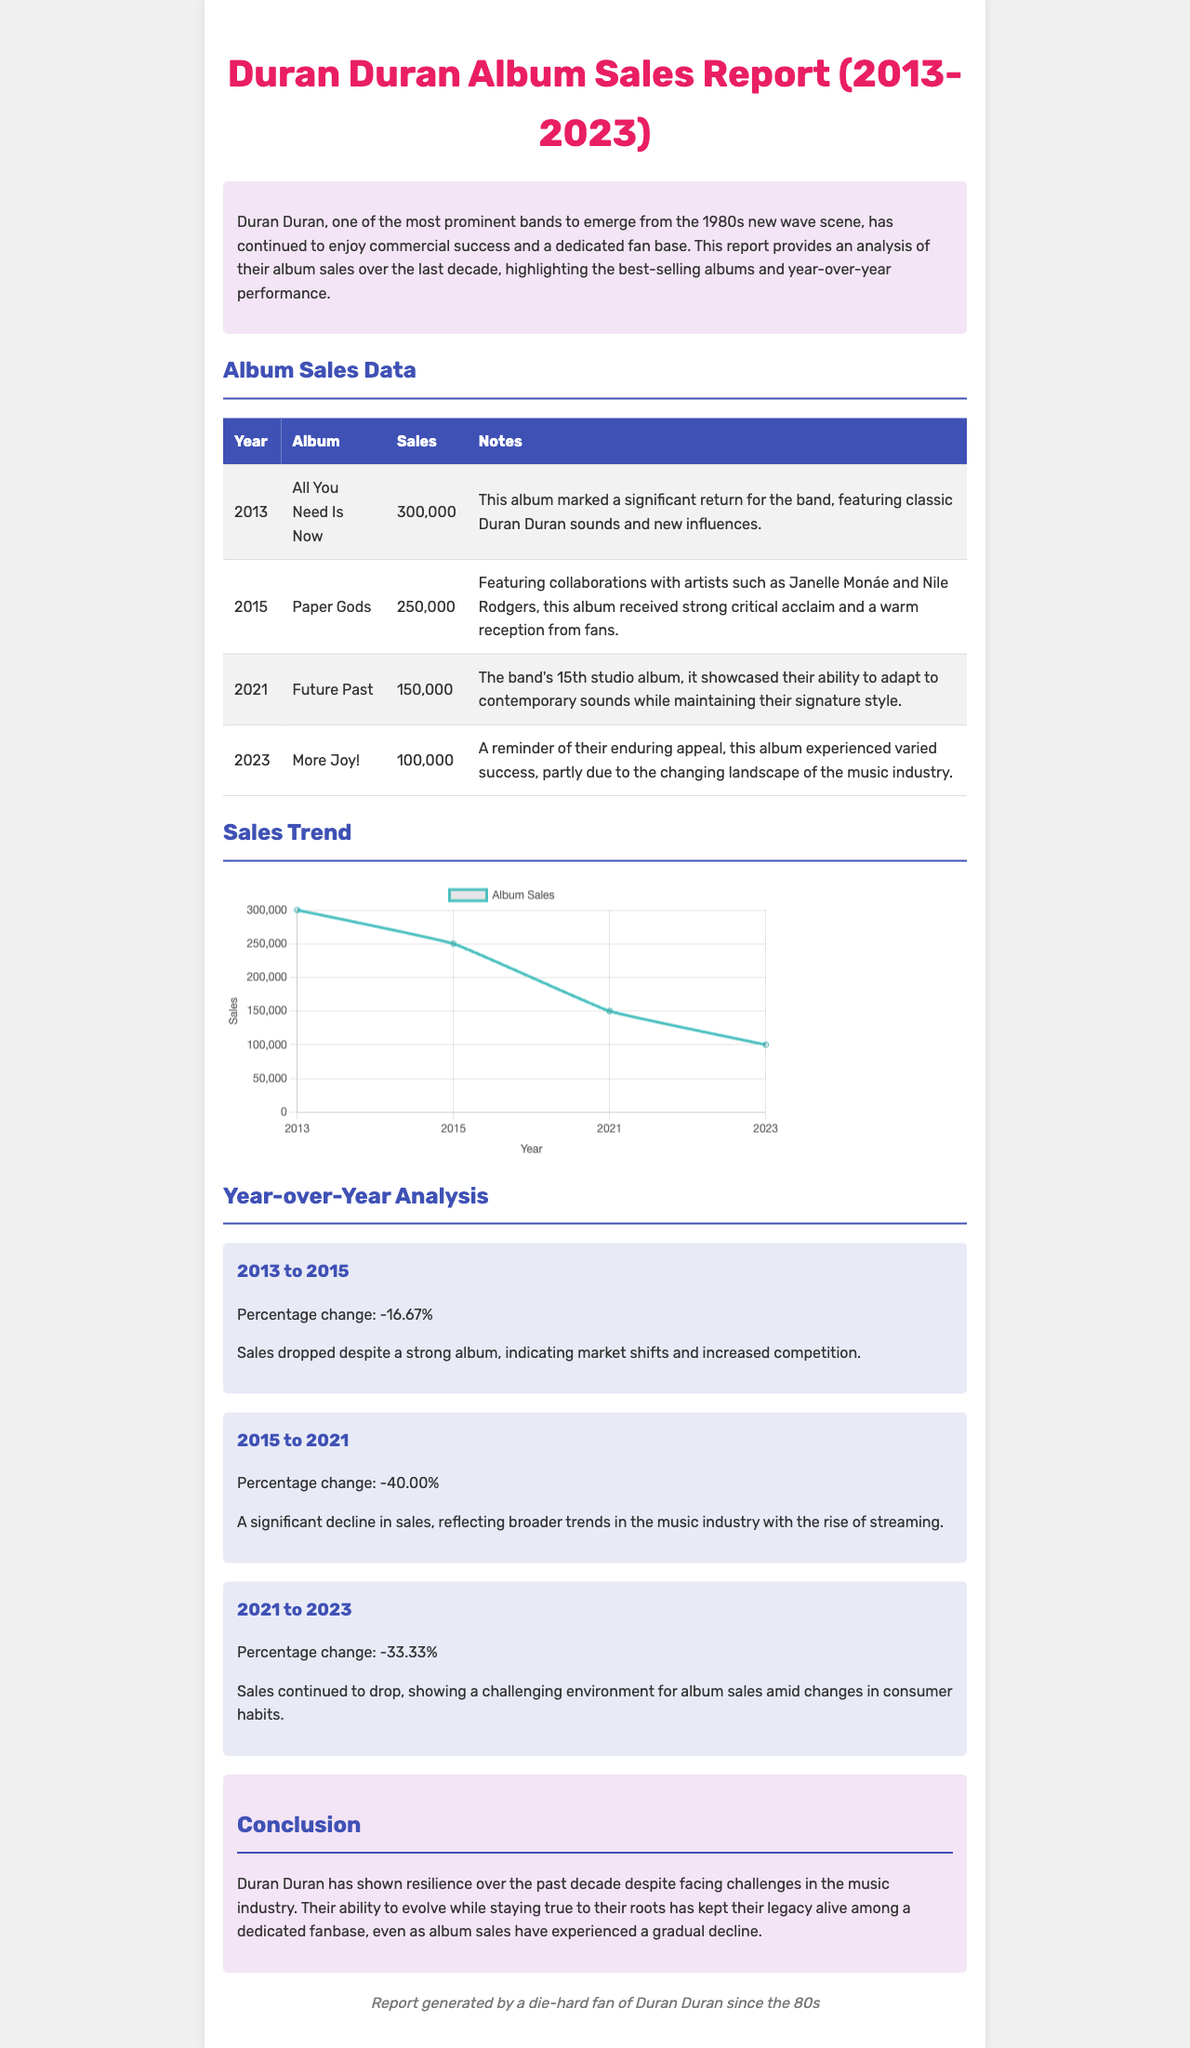What is the best-selling album in 2013? The best-selling album in 2013, as stated in the document, is "All You Need Is Now" with sales of 300,000 copies.
Answer: All You Need Is Now What were the sales for the album "Paper Gods"? The document specifies that "Paper Gods" sold 250,000 copies.
Answer: 250,000 What year was the album "Future Past" released? According to the document, "Future Past" was released in 2021.
Answer: 2021 What percentage change in sales occurred from 2013 to 2015? The report notes that the percentage change in sales from 2013 to 2015 was -16.67%.
Answer: -16.67% Which album experienced varied success in 2023? The document mentions that "More Joy!" experienced varied success in 2023.
Answer: More Joy! What does the year-over-year analysis show for 2021 to 2023? The analysis signifies a percentage change of -33.33% in sales from 2021 to 2023.
Answer: -33.33% What is the total sales figure for albums from 2013 to 2023? The total sales figure is the sum of all listed album sales: 300,000 + 250,000 + 150,000 + 100,000 = 800,000.
Answer: 800,000 What notable event happened in 2013 for Duran Duran? The report highlights that 2013 marked a significant return for the band with the album "All You Need Is Now."
Answer: Significant return 